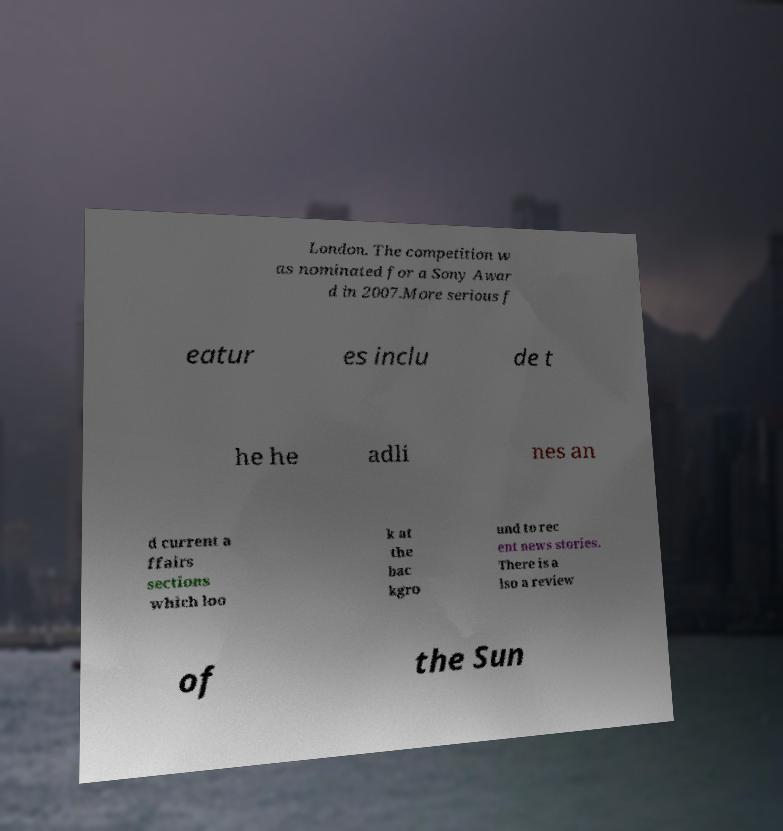Can you read and provide the text displayed in the image?This photo seems to have some interesting text. Can you extract and type it out for me? London. The competition w as nominated for a Sony Awar d in 2007.More serious f eatur es inclu de t he he adli nes an d current a ffairs sections which loo k at the bac kgro und to rec ent news stories. There is a lso a review of the Sun 